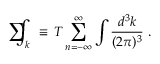<formula> <loc_0><loc_0><loc_500><loc_500>\sum \, \int _ { k } \equiv \, T \sum _ { n = - \infty } ^ { \infty } \int { \frac { d ^ { 3 } k } { ( 2 \pi ) ^ { 3 } } } .</formula> 